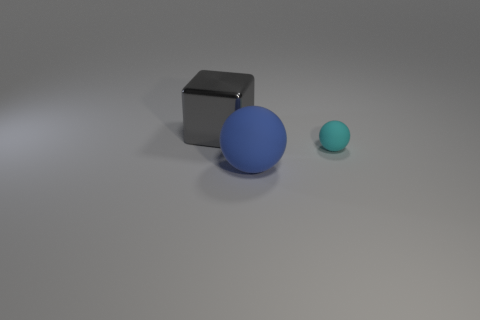Imagine these objects are part of an artwork. What title would you give to it? Considering their simple yet distinct forms, I would title it 'Harmony in Geometry' to reflect the balance and contrast of shapes and colors in the arrangement. 